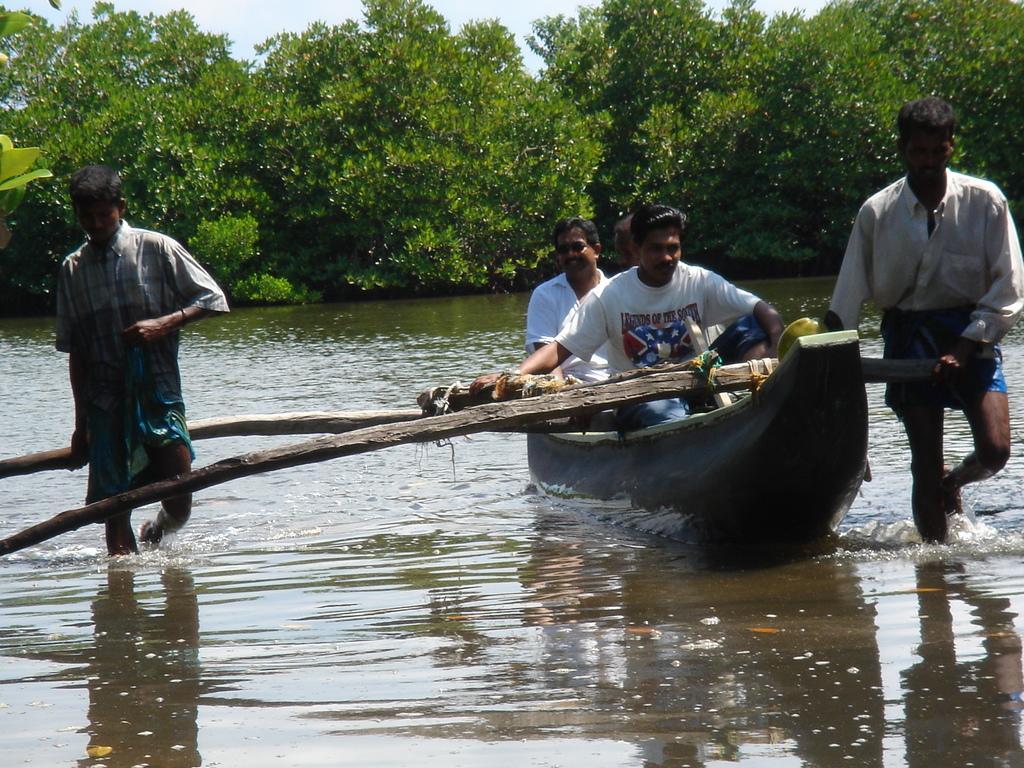Could you give a brief overview of what you see in this image? In the picture we can see water and boat in it with two men moving it with a stick and on the other sides we can see two men are walking in the water, in the background we can see some bushes and plants and a sky. 